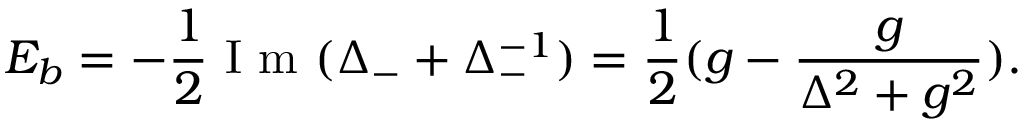Convert formula to latex. <formula><loc_0><loc_0><loc_500><loc_500>E _ { b } = - \frac { 1 } { 2 } I m ( \Delta _ { - } + \Delta _ { - } ^ { - 1 } ) = \frac { 1 } { 2 } ( g - \frac { g } { \Delta ^ { 2 } + g ^ { 2 } } ) .</formula> 